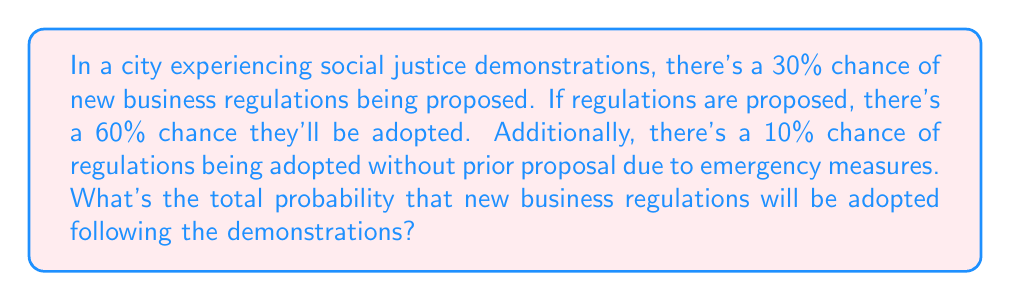Teach me how to tackle this problem. Let's approach this step-by-step:

1) Define events:
   A: Regulations are adopted
   P: Regulations are proposed

2) Given probabilities:
   $P(P) = 0.30$ (30% chance of proposals)
   $P(A|P) = 0.60$ (60% chance of adoption if proposed)
   $P(A|\text{not }P) = 0.10$ (10% chance of adoption without proposal)

3) We need to find $P(A)$, which can be calculated using the law of total probability:

   $P(A) = P(A|P) \cdot P(P) + P(A|\text{not }P) \cdot P(\text{not }P)$

4) We know $P(P) = 0.30$, so $P(\text{not }P) = 1 - P(P) = 0.70$

5) Substituting the values:

   $P(A) = 0.60 \cdot 0.30 + 0.10 \cdot 0.70$

6) Calculating:
   $P(A) = 0.18 + 0.07 = 0.25$

Therefore, the total probability of new business regulations being adopted is 0.25 or 25%.
Answer: 0.25 